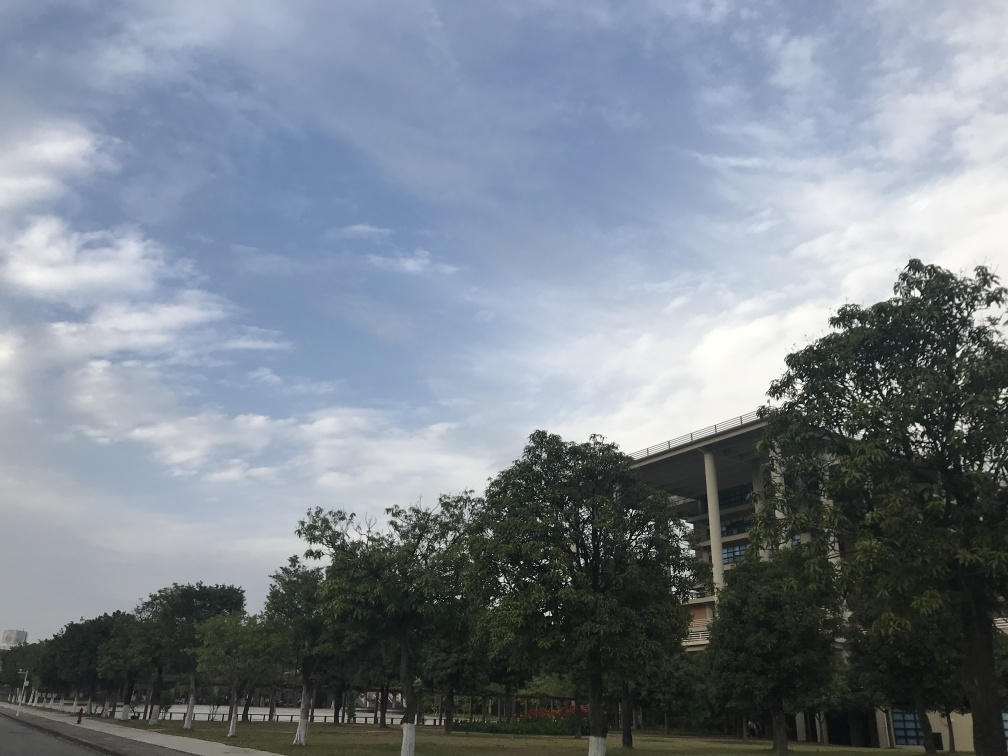Does the picture lack clarity?
 No 